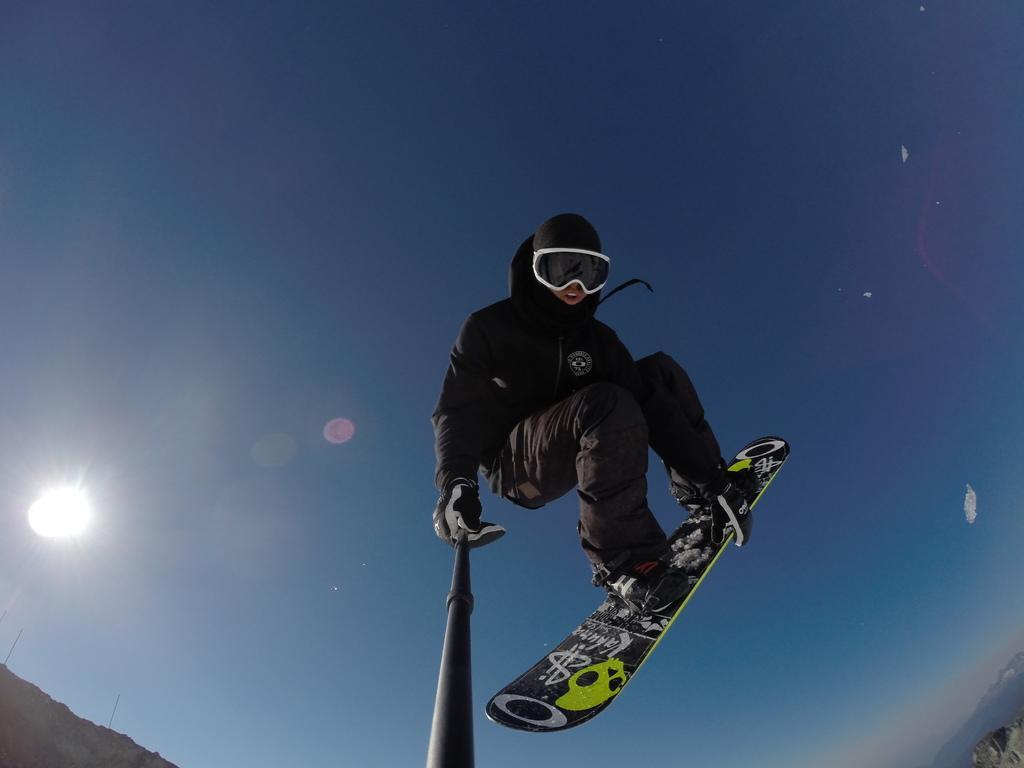In one or two sentences, can you explain what this image depicts? This image is taken outdoors. At the top of the image there is a sky with sun and clouds. In the middle of the image there is a person with a skating board and he is holding a stick in his hand. 